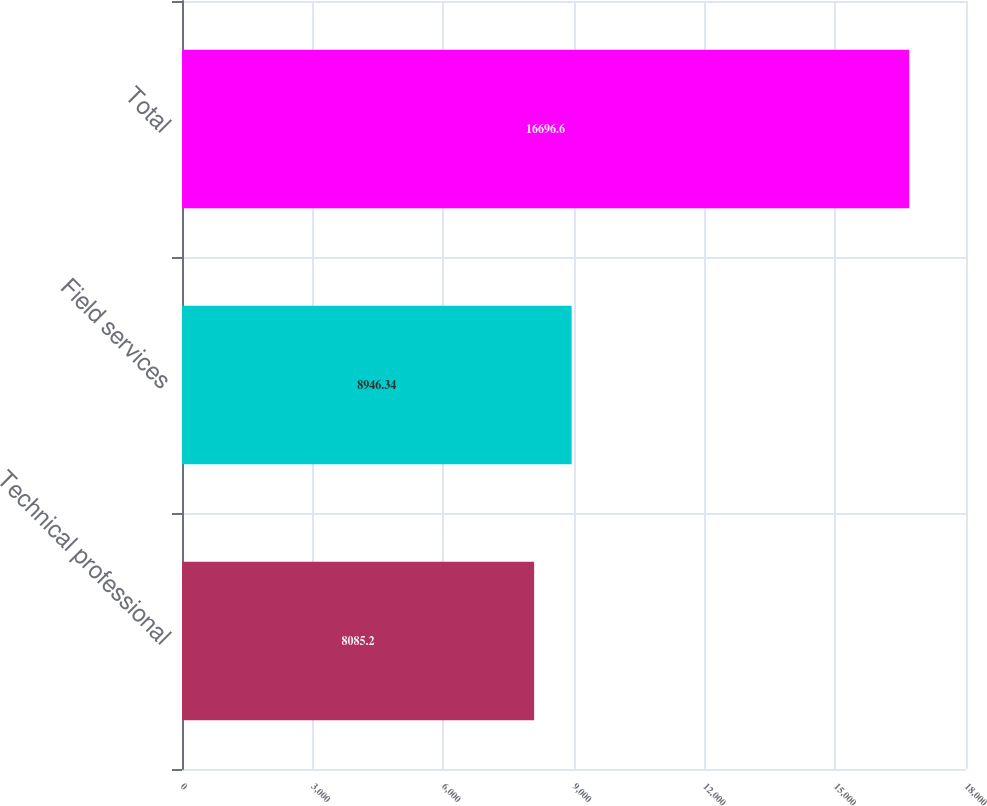<chart> <loc_0><loc_0><loc_500><loc_500><bar_chart><fcel>Technical professional<fcel>Field services<fcel>Total<nl><fcel>8085.2<fcel>8946.34<fcel>16696.6<nl></chart> 